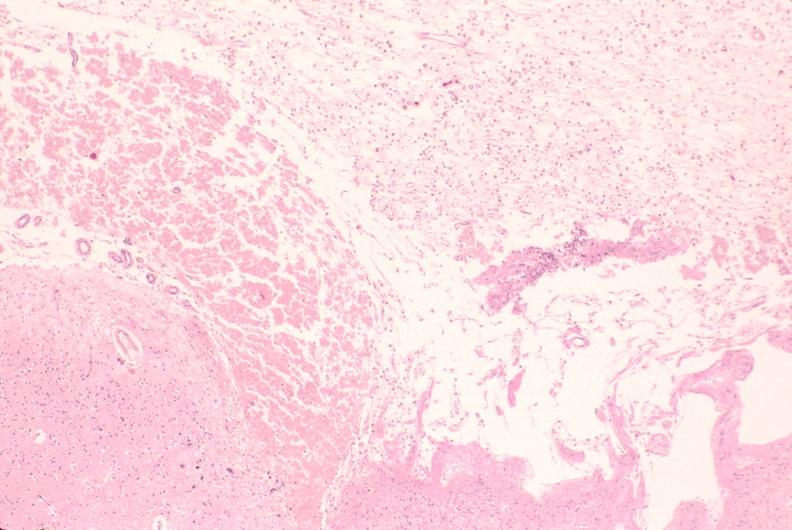what does this image show?
Answer the question using a single word or phrase. Brain 